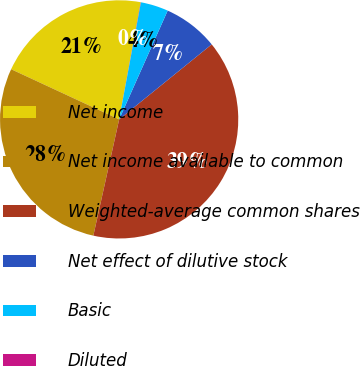<chart> <loc_0><loc_0><loc_500><loc_500><pie_chart><fcel>Net income<fcel>Net income available to common<fcel>Weighted-average common shares<fcel>Net effect of dilutive stock<fcel>Basic<fcel>Diluted<nl><fcel>20.98%<fcel>28.44%<fcel>39.32%<fcel>7.48%<fcel>3.75%<fcel>0.03%<nl></chart> 